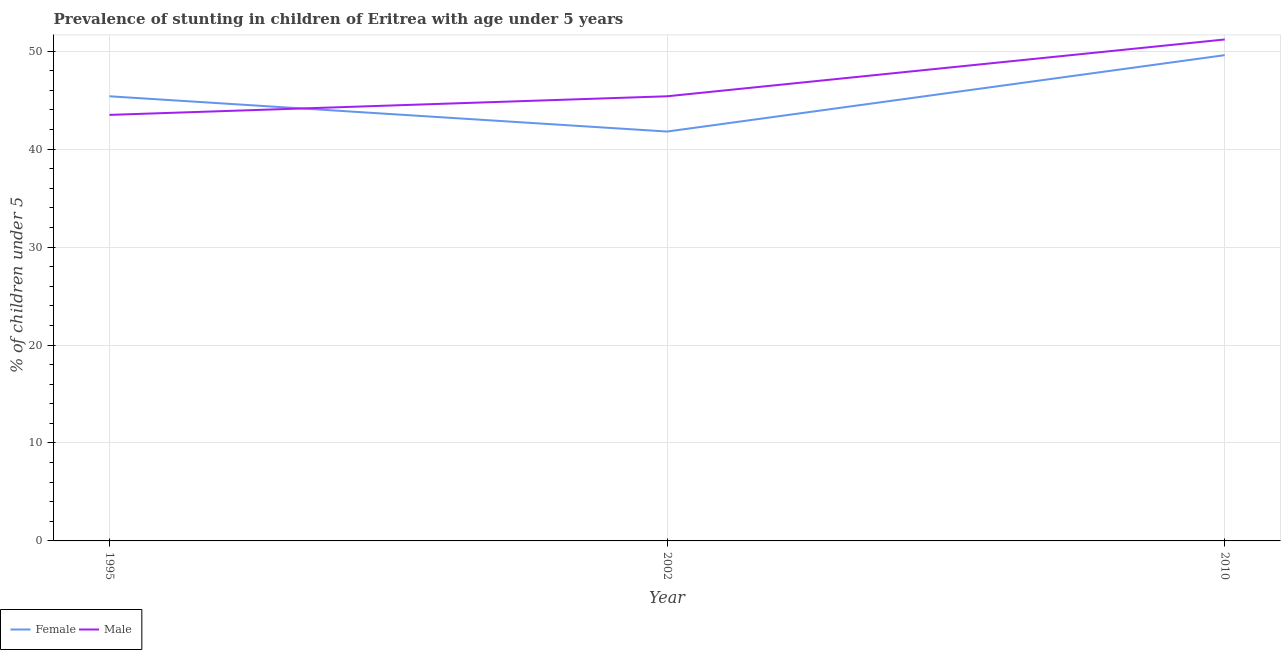How many different coloured lines are there?
Your response must be concise. 2. Does the line corresponding to percentage of stunted female children intersect with the line corresponding to percentage of stunted male children?
Provide a succinct answer. Yes. What is the percentage of stunted female children in 2002?
Give a very brief answer. 41.8. Across all years, what is the maximum percentage of stunted male children?
Provide a short and direct response. 51.2. Across all years, what is the minimum percentage of stunted female children?
Your response must be concise. 41.8. In which year was the percentage of stunted male children minimum?
Keep it short and to the point. 1995. What is the total percentage of stunted male children in the graph?
Keep it short and to the point. 140.1. What is the difference between the percentage of stunted female children in 1995 and that in 2010?
Your response must be concise. -4.2. What is the difference between the percentage of stunted male children in 2002 and the percentage of stunted female children in 2010?
Your answer should be very brief. -4.2. What is the average percentage of stunted female children per year?
Your answer should be compact. 45.6. In the year 2010, what is the difference between the percentage of stunted female children and percentage of stunted male children?
Your answer should be compact. -1.6. What is the ratio of the percentage of stunted female children in 1995 to that in 2002?
Your answer should be very brief. 1.09. Is the percentage of stunted female children in 1995 less than that in 2010?
Your answer should be compact. Yes. Is the difference between the percentage of stunted male children in 1995 and 2002 greater than the difference between the percentage of stunted female children in 1995 and 2002?
Give a very brief answer. No. What is the difference between the highest and the second highest percentage of stunted male children?
Make the answer very short. 5.8. What is the difference between the highest and the lowest percentage of stunted female children?
Provide a short and direct response. 7.8. In how many years, is the percentage of stunted female children greater than the average percentage of stunted female children taken over all years?
Offer a terse response. 1. Is the sum of the percentage of stunted male children in 1995 and 2002 greater than the maximum percentage of stunted female children across all years?
Give a very brief answer. Yes. How many lines are there?
Your response must be concise. 2. How many years are there in the graph?
Provide a short and direct response. 3. What is the difference between two consecutive major ticks on the Y-axis?
Your answer should be very brief. 10. Does the graph contain any zero values?
Your answer should be very brief. No. How many legend labels are there?
Provide a succinct answer. 2. How are the legend labels stacked?
Your answer should be very brief. Horizontal. What is the title of the graph?
Make the answer very short. Prevalence of stunting in children of Eritrea with age under 5 years. Does "Resident" appear as one of the legend labels in the graph?
Provide a succinct answer. No. What is the label or title of the Y-axis?
Keep it short and to the point.  % of children under 5. What is the  % of children under 5 of Female in 1995?
Provide a succinct answer. 45.4. What is the  % of children under 5 in Male in 1995?
Ensure brevity in your answer.  43.5. What is the  % of children under 5 of Female in 2002?
Make the answer very short. 41.8. What is the  % of children under 5 in Male in 2002?
Offer a very short reply. 45.4. What is the  % of children under 5 in Female in 2010?
Give a very brief answer. 49.6. What is the  % of children under 5 in Male in 2010?
Your answer should be compact. 51.2. Across all years, what is the maximum  % of children under 5 in Female?
Give a very brief answer. 49.6. Across all years, what is the maximum  % of children under 5 of Male?
Ensure brevity in your answer.  51.2. Across all years, what is the minimum  % of children under 5 of Female?
Your response must be concise. 41.8. Across all years, what is the minimum  % of children under 5 in Male?
Your answer should be compact. 43.5. What is the total  % of children under 5 in Female in the graph?
Offer a terse response. 136.8. What is the total  % of children under 5 of Male in the graph?
Your answer should be very brief. 140.1. What is the difference between the  % of children under 5 in Female in 1995 and that in 2002?
Provide a short and direct response. 3.6. What is the difference between the  % of children under 5 of Male in 1995 and that in 2002?
Keep it short and to the point. -1.9. What is the difference between the  % of children under 5 in Female in 1995 and that in 2010?
Your answer should be compact. -4.2. What is the difference between the  % of children under 5 in Male in 1995 and that in 2010?
Give a very brief answer. -7.7. What is the difference between the  % of children under 5 in Female in 2002 and that in 2010?
Offer a very short reply. -7.8. What is the difference between the  % of children under 5 of Male in 2002 and that in 2010?
Ensure brevity in your answer.  -5.8. What is the difference between the  % of children under 5 of Female in 1995 and the  % of children under 5 of Male in 2010?
Provide a succinct answer. -5.8. What is the average  % of children under 5 in Female per year?
Your answer should be very brief. 45.6. What is the average  % of children under 5 in Male per year?
Offer a very short reply. 46.7. In the year 1995, what is the difference between the  % of children under 5 of Female and  % of children under 5 of Male?
Your response must be concise. 1.9. What is the ratio of the  % of children under 5 of Female in 1995 to that in 2002?
Offer a very short reply. 1.09. What is the ratio of the  % of children under 5 in Male in 1995 to that in 2002?
Give a very brief answer. 0.96. What is the ratio of the  % of children under 5 of Female in 1995 to that in 2010?
Keep it short and to the point. 0.92. What is the ratio of the  % of children under 5 in Male in 1995 to that in 2010?
Ensure brevity in your answer.  0.85. What is the ratio of the  % of children under 5 in Female in 2002 to that in 2010?
Your response must be concise. 0.84. What is the ratio of the  % of children under 5 in Male in 2002 to that in 2010?
Your response must be concise. 0.89. What is the difference between the highest and the second highest  % of children under 5 in Female?
Your response must be concise. 4.2. 